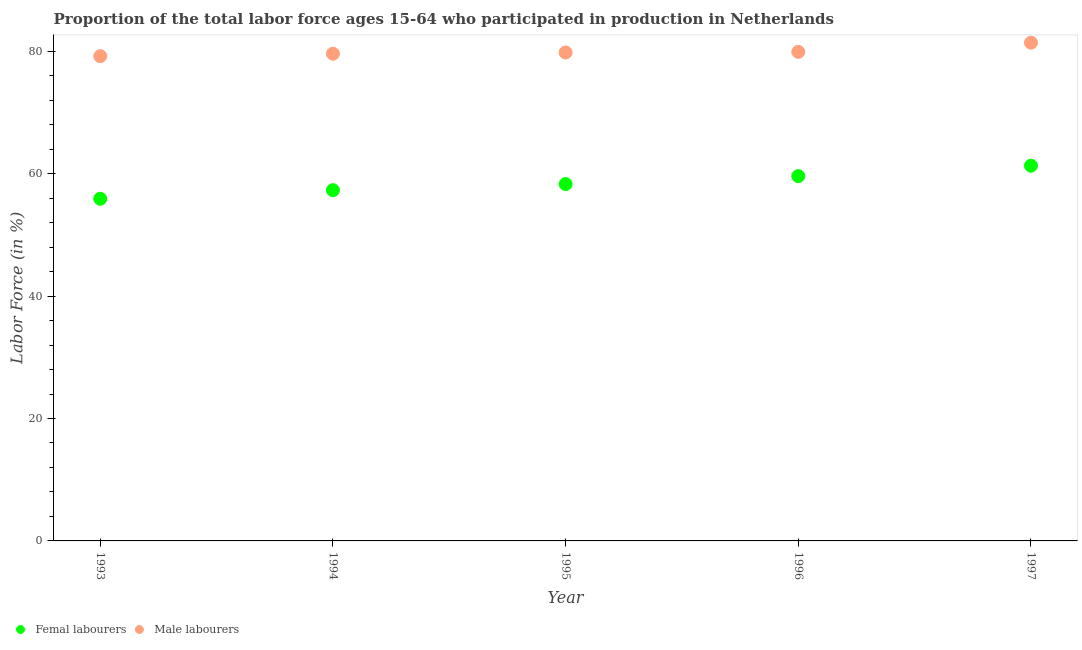How many different coloured dotlines are there?
Your answer should be very brief. 2. Is the number of dotlines equal to the number of legend labels?
Your response must be concise. Yes. What is the percentage of female labor force in 1994?
Make the answer very short. 57.3. Across all years, what is the maximum percentage of female labor force?
Your response must be concise. 61.3. Across all years, what is the minimum percentage of male labour force?
Your answer should be very brief. 79.2. What is the total percentage of male labour force in the graph?
Ensure brevity in your answer.  399.9. What is the difference between the percentage of female labor force in 1995 and that in 1997?
Provide a succinct answer. -3. What is the difference between the percentage of male labour force in 1996 and the percentage of female labor force in 1995?
Your answer should be compact. 21.6. What is the average percentage of female labor force per year?
Provide a short and direct response. 58.48. In the year 1996, what is the difference between the percentage of male labour force and percentage of female labor force?
Offer a terse response. 20.3. In how many years, is the percentage of male labour force greater than 56 %?
Provide a short and direct response. 5. What is the ratio of the percentage of male labour force in 1995 to that in 1996?
Your answer should be very brief. 1. Is the percentage of male labour force in 1995 less than that in 1996?
Your answer should be compact. Yes. What is the difference between the highest and the lowest percentage of female labor force?
Provide a succinct answer. 5.4. In how many years, is the percentage of female labor force greater than the average percentage of female labor force taken over all years?
Make the answer very short. 2. Is the sum of the percentage of female labor force in 1993 and 1995 greater than the maximum percentage of male labour force across all years?
Make the answer very short. Yes. Does the percentage of male labour force monotonically increase over the years?
Ensure brevity in your answer.  Yes. Is the percentage of male labour force strictly less than the percentage of female labor force over the years?
Make the answer very short. No. How many dotlines are there?
Ensure brevity in your answer.  2. How many years are there in the graph?
Your answer should be compact. 5. What is the difference between two consecutive major ticks on the Y-axis?
Offer a very short reply. 20. Are the values on the major ticks of Y-axis written in scientific E-notation?
Offer a very short reply. No. Does the graph contain grids?
Your response must be concise. No. Where does the legend appear in the graph?
Give a very brief answer. Bottom left. How are the legend labels stacked?
Provide a succinct answer. Horizontal. What is the title of the graph?
Ensure brevity in your answer.  Proportion of the total labor force ages 15-64 who participated in production in Netherlands. Does "Overweight" appear as one of the legend labels in the graph?
Your response must be concise. No. What is the label or title of the X-axis?
Ensure brevity in your answer.  Year. What is the Labor Force (in %) in Femal labourers in 1993?
Your response must be concise. 55.9. What is the Labor Force (in %) in Male labourers in 1993?
Offer a very short reply. 79.2. What is the Labor Force (in %) of Femal labourers in 1994?
Your answer should be very brief. 57.3. What is the Labor Force (in %) in Male labourers in 1994?
Your response must be concise. 79.6. What is the Labor Force (in %) of Femal labourers in 1995?
Your answer should be compact. 58.3. What is the Labor Force (in %) of Male labourers in 1995?
Your answer should be compact. 79.8. What is the Labor Force (in %) of Femal labourers in 1996?
Give a very brief answer. 59.6. What is the Labor Force (in %) in Male labourers in 1996?
Provide a short and direct response. 79.9. What is the Labor Force (in %) in Femal labourers in 1997?
Offer a very short reply. 61.3. What is the Labor Force (in %) of Male labourers in 1997?
Provide a short and direct response. 81.4. Across all years, what is the maximum Labor Force (in %) in Femal labourers?
Your answer should be compact. 61.3. Across all years, what is the maximum Labor Force (in %) in Male labourers?
Ensure brevity in your answer.  81.4. Across all years, what is the minimum Labor Force (in %) in Femal labourers?
Provide a short and direct response. 55.9. Across all years, what is the minimum Labor Force (in %) in Male labourers?
Your response must be concise. 79.2. What is the total Labor Force (in %) in Femal labourers in the graph?
Offer a terse response. 292.4. What is the total Labor Force (in %) in Male labourers in the graph?
Provide a short and direct response. 399.9. What is the difference between the Labor Force (in %) in Femal labourers in 1993 and that in 1994?
Give a very brief answer. -1.4. What is the difference between the Labor Force (in %) in Male labourers in 1993 and that in 1994?
Offer a terse response. -0.4. What is the difference between the Labor Force (in %) of Femal labourers in 1993 and that in 1995?
Make the answer very short. -2.4. What is the difference between the Labor Force (in %) in Male labourers in 1993 and that in 1997?
Provide a short and direct response. -2.2. What is the difference between the Labor Force (in %) in Femal labourers in 1994 and that in 1996?
Provide a succinct answer. -2.3. What is the difference between the Labor Force (in %) in Male labourers in 1994 and that in 1996?
Offer a very short reply. -0.3. What is the difference between the Labor Force (in %) in Femal labourers in 1995 and that in 1996?
Provide a succinct answer. -1.3. What is the difference between the Labor Force (in %) of Male labourers in 1995 and that in 1997?
Ensure brevity in your answer.  -1.6. What is the difference between the Labor Force (in %) of Femal labourers in 1996 and that in 1997?
Provide a short and direct response. -1.7. What is the difference between the Labor Force (in %) of Male labourers in 1996 and that in 1997?
Offer a very short reply. -1.5. What is the difference between the Labor Force (in %) in Femal labourers in 1993 and the Labor Force (in %) in Male labourers in 1994?
Offer a very short reply. -23.7. What is the difference between the Labor Force (in %) of Femal labourers in 1993 and the Labor Force (in %) of Male labourers in 1995?
Ensure brevity in your answer.  -23.9. What is the difference between the Labor Force (in %) of Femal labourers in 1993 and the Labor Force (in %) of Male labourers in 1996?
Offer a very short reply. -24. What is the difference between the Labor Force (in %) of Femal labourers in 1993 and the Labor Force (in %) of Male labourers in 1997?
Your answer should be compact. -25.5. What is the difference between the Labor Force (in %) in Femal labourers in 1994 and the Labor Force (in %) in Male labourers in 1995?
Ensure brevity in your answer.  -22.5. What is the difference between the Labor Force (in %) of Femal labourers in 1994 and the Labor Force (in %) of Male labourers in 1996?
Your answer should be very brief. -22.6. What is the difference between the Labor Force (in %) in Femal labourers in 1994 and the Labor Force (in %) in Male labourers in 1997?
Offer a very short reply. -24.1. What is the difference between the Labor Force (in %) of Femal labourers in 1995 and the Labor Force (in %) of Male labourers in 1996?
Give a very brief answer. -21.6. What is the difference between the Labor Force (in %) in Femal labourers in 1995 and the Labor Force (in %) in Male labourers in 1997?
Offer a very short reply. -23.1. What is the difference between the Labor Force (in %) in Femal labourers in 1996 and the Labor Force (in %) in Male labourers in 1997?
Offer a terse response. -21.8. What is the average Labor Force (in %) in Femal labourers per year?
Provide a succinct answer. 58.48. What is the average Labor Force (in %) of Male labourers per year?
Keep it short and to the point. 79.98. In the year 1993, what is the difference between the Labor Force (in %) of Femal labourers and Labor Force (in %) of Male labourers?
Provide a short and direct response. -23.3. In the year 1994, what is the difference between the Labor Force (in %) in Femal labourers and Labor Force (in %) in Male labourers?
Offer a terse response. -22.3. In the year 1995, what is the difference between the Labor Force (in %) in Femal labourers and Labor Force (in %) in Male labourers?
Provide a short and direct response. -21.5. In the year 1996, what is the difference between the Labor Force (in %) of Femal labourers and Labor Force (in %) of Male labourers?
Ensure brevity in your answer.  -20.3. In the year 1997, what is the difference between the Labor Force (in %) in Femal labourers and Labor Force (in %) in Male labourers?
Your response must be concise. -20.1. What is the ratio of the Labor Force (in %) in Femal labourers in 1993 to that in 1994?
Give a very brief answer. 0.98. What is the ratio of the Labor Force (in %) in Male labourers in 1993 to that in 1994?
Make the answer very short. 0.99. What is the ratio of the Labor Force (in %) of Femal labourers in 1993 to that in 1995?
Keep it short and to the point. 0.96. What is the ratio of the Labor Force (in %) of Male labourers in 1993 to that in 1995?
Ensure brevity in your answer.  0.99. What is the ratio of the Labor Force (in %) of Femal labourers in 1993 to that in 1996?
Offer a terse response. 0.94. What is the ratio of the Labor Force (in %) of Femal labourers in 1993 to that in 1997?
Keep it short and to the point. 0.91. What is the ratio of the Labor Force (in %) in Male labourers in 1993 to that in 1997?
Ensure brevity in your answer.  0.97. What is the ratio of the Labor Force (in %) of Femal labourers in 1994 to that in 1995?
Make the answer very short. 0.98. What is the ratio of the Labor Force (in %) of Femal labourers in 1994 to that in 1996?
Ensure brevity in your answer.  0.96. What is the ratio of the Labor Force (in %) of Male labourers in 1994 to that in 1996?
Your answer should be very brief. 1. What is the ratio of the Labor Force (in %) in Femal labourers in 1994 to that in 1997?
Keep it short and to the point. 0.93. What is the ratio of the Labor Force (in %) in Male labourers in 1994 to that in 1997?
Keep it short and to the point. 0.98. What is the ratio of the Labor Force (in %) in Femal labourers in 1995 to that in 1996?
Offer a very short reply. 0.98. What is the ratio of the Labor Force (in %) of Male labourers in 1995 to that in 1996?
Your answer should be compact. 1. What is the ratio of the Labor Force (in %) in Femal labourers in 1995 to that in 1997?
Ensure brevity in your answer.  0.95. What is the ratio of the Labor Force (in %) in Male labourers in 1995 to that in 1997?
Provide a succinct answer. 0.98. What is the ratio of the Labor Force (in %) in Femal labourers in 1996 to that in 1997?
Your answer should be compact. 0.97. What is the ratio of the Labor Force (in %) of Male labourers in 1996 to that in 1997?
Offer a very short reply. 0.98. What is the difference between the highest and the second highest Labor Force (in %) in Femal labourers?
Keep it short and to the point. 1.7. What is the difference between the highest and the second highest Labor Force (in %) of Male labourers?
Offer a terse response. 1.5. What is the difference between the highest and the lowest Labor Force (in %) in Femal labourers?
Offer a very short reply. 5.4. What is the difference between the highest and the lowest Labor Force (in %) of Male labourers?
Keep it short and to the point. 2.2. 